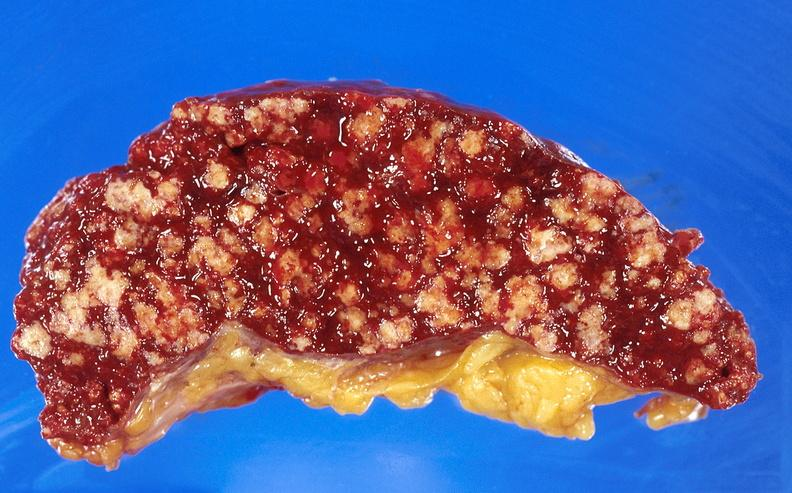does chest and abdomen slide show spleen, tuberculosis?
Answer the question using a single word or phrase. No 